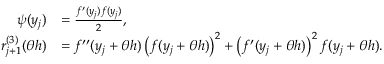<formula> <loc_0><loc_0><loc_500><loc_500>\begin{array} { r l } { \psi ( y _ { j } ) } & { = \frac { f ^ { \prime } ( y _ { j } ) f ( y _ { j } ) } { 2 } , } \\ { r _ { j + 1 } ^ { ( 3 ) } ( \theta h ) } & { = f ^ { \prime \prime } ( y _ { j } + \theta h ) \left ( f ( y _ { j } + \theta h ) \right ) ^ { 2 } + \left ( f ^ { \prime } ( y _ { j } + \theta h ) \right ) ^ { 2 } f ( y _ { j } + \theta h ) . } \end{array}</formula> 